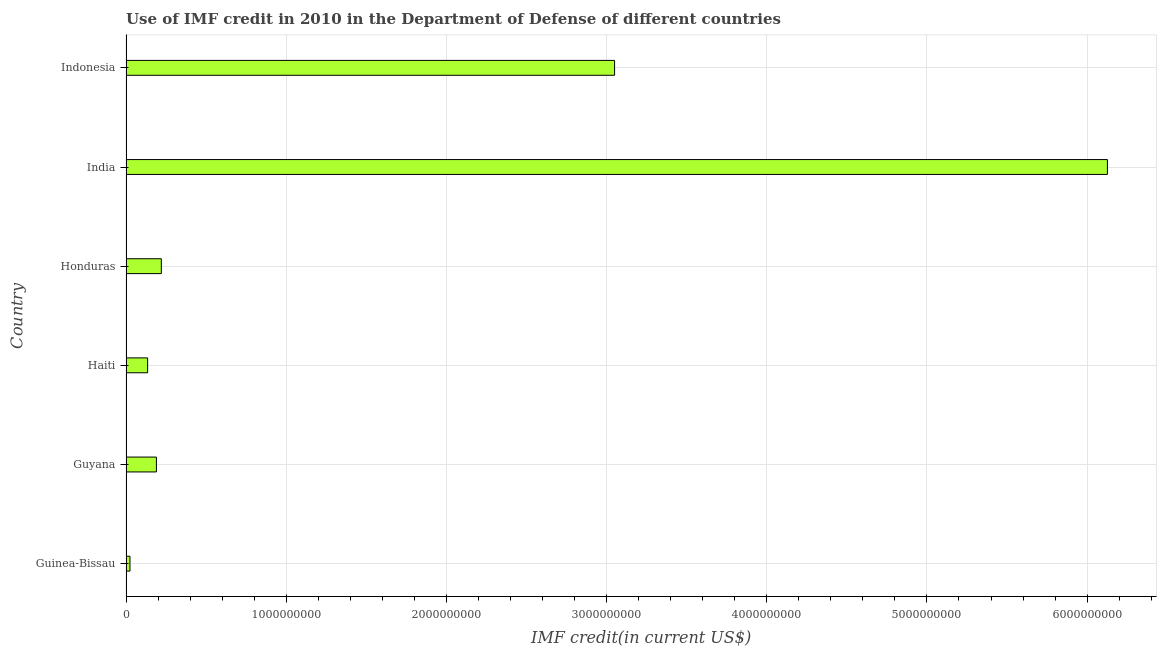What is the title of the graph?
Make the answer very short. Use of IMF credit in 2010 in the Department of Defense of different countries. What is the label or title of the X-axis?
Provide a short and direct response. IMF credit(in current US$). What is the use of imf credit in dod in Guyana?
Give a very brief answer. 1.90e+08. Across all countries, what is the maximum use of imf credit in dod?
Make the answer very short. 6.13e+09. Across all countries, what is the minimum use of imf credit in dod?
Ensure brevity in your answer.  2.47e+07. In which country was the use of imf credit in dod maximum?
Offer a very short reply. India. In which country was the use of imf credit in dod minimum?
Your answer should be compact. Guinea-Bissau. What is the sum of the use of imf credit in dod?
Make the answer very short. 9.75e+09. What is the difference between the use of imf credit in dod in Honduras and Indonesia?
Provide a short and direct response. -2.83e+09. What is the average use of imf credit in dod per country?
Offer a very short reply. 1.62e+09. What is the median use of imf credit in dod?
Your answer should be compact. 2.05e+08. In how many countries, is the use of imf credit in dod greater than 1800000000 US$?
Offer a terse response. 2. What is the ratio of the use of imf credit in dod in Guinea-Bissau to that in Haiti?
Your response must be concise. 0.18. Is the use of imf credit in dod in Honduras less than that in India?
Your answer should be compact. Yes. Is the difference between the use of imf credit in dod in India and Indonesia greater than the difference between any two countries?
Make the answer very short. No. What is the difference between the highest and the second highest use of imf credit in dod?
Ensure brevity in your answer.  3.08e+09. Is the sum of the use of imf credit in dod in Guinea-Bissau and India greater than the maximum use of imf credit in dod across all countries?
Provide a succinct answer. Yes. What is the difference between the highest and the lowest use of imf credit in dod?
Make the answer very short. 6.10e+09. How many bars are there?
Offer a terse response. 6. What is the difference between two consecutive major ticks on the X-axis?
Your response must be concise. 1.00e+09. What is the IMF credit(in current US$) in Guinea-Bissau?
Give a very brief answer. 2.47e+07. What is the IMF credit(in current US$) of Guyana?
Offer a very short reply. 1.90e+08. What is the IMF credit(in current US$) of Haiti?
Ensure brevity in your answer.  1.35e+08. What is the IMF credit(in current US$) of Honduras?
Your response must be concise. 2.20e+08. What is the IMF credit(in current US$) of India?
Your response must be concise. 6.13e+09. What is the IMF credit(in current US$) in Indonesia?
Ensure brevity in your answer.  3.05e+09. What is the difference between the IMF credit(in current US$) in Guinea-Bissau and Guyana?
Your response must be concise. -1.65e+08. What is the difference between the IMF credit(in current US$) in Guinea-Bissau and Haiti?
Make the answer very short. -1.10e+08. What is the difference between the IMF credit(in current US$) in Guinea-Bissau and Honduras?
Offer a very short reply. -1.96e+08. What is the difference between the IMF credit(in current US$) in Guinea-Bissau and India?
Your response must be concise. -6.10e+09. What is the difference between the IMF credit(in current US$) in Guinea-Bissau and Indonesia?
Your response must be concise. -3.03e+09. What is the difference between the IMF credit(in current US$) in Guyana and Haiti?
Offer a terse response. 5.48e+07. What is the difference between the IMF credit(in current US$) in Guyana and Honduras?
Make the answer very short. -3.07e+07. What is the difference between the IMF credit(in current US$) in Guyana and India?
Make the answer very short. -5.94e+09. What is the difference between the IMF credit(in current US$) in Guyana and Indonesia?
Your response must be concise. -2.86e+09. What is the difference between the IMF credit(in current US$) in Haiti and Honduras?
Your response must be concise. -8.56e+07. What is the difference between the IMF credit(in current US$) in Haiti and India?
Offer a terse response. -5.99e+09. What is the difference between the IMF credit(in current US$) in Haiti and Indonesia?
Your answer should be compact. -2.92e+09. What is the difference between the IMF credit(in current US$) in Honduras and India?
Provide a short and direct response. -5.91e+09. What is the difference between the IMF credit(in current US$) in Honduras and Indonesia?
Keep it short and to the point. -2.83e+09. What is the difference between the IMF credit(in current US$) in India and Indonesia?
Provide a short and direct response. 3.08e+09. What is the ratio of the IMF credit(in current US$) in Guinea-Bissau to that in Guyana?
Offer a terse response. 0.13. What is the ratio of the IMF credit(in current US$) in Guinea-Bissau to that in Haiti?
Your answer should be compact. 0.18. What is the ratio of the IMF credit(in current US$) in Guinea-Bissau to that in Honduras?
Your answer should be very brief. 0.11. What is the ratio of the IMF credit(in current US$) in Guinea-Bissau to that in India?
Make the answer very short. 0. What is the ratio of the IMF credit(in current US$) in Guinea-Bissau to that in Indonesia?
Provide a short and direct response. 0.01. What is the ratio of the IMF credit(in current US$) in Guyana to that in Haiti?
Give a very brief answer. 1.41. What is the ratio of the IMF credit(in current US$) in Guyana to that in Honduras?
Keep it short and to the point. 0.86. What is the ratio of the IMF credit(in current US$) in Guyana to that in India?
Your response must be concise. 0.03. What is the ratio of the IMF credit(in current US$) in Guyana to that in Indonesia?
Your answer should be compact. 0.06. What is the ratio of the IMF credit(in current US$) in Haiti to that in Honduras?
Give a very brief answer. 0.61. What is the ratio of the IMF credit(in current US$) in Haiti to that in India?
Provide a succinct answer. 0.02. What is the ratio of the IMF credit(in current US$) in Haiti to that in Indonesia?
Keep it short and to the point. 0.04. What is the ratio of the IMF credit(in current US$) in Honduras to that in India?
Make the answer very short. 0.04. What is the ratio of the IMF credit(in current US$) in Honduras to that in Indonesia?
Your answer should be very brief. 0.07. What is the ratio of the IMF credit(in current US$) in India to that in Indonesia?
Provide a succinct answer. 2.01. 